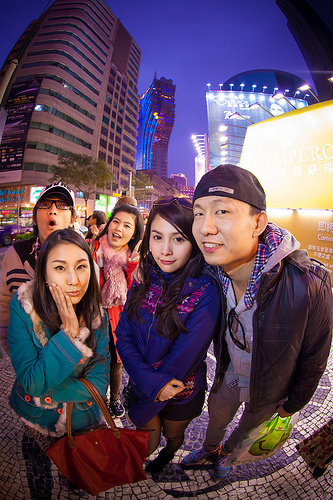<image>
Is the bag on the girl? Yes. Looking at the image, I can see the bag is positioned on top of the girl, with the girl providing support. 